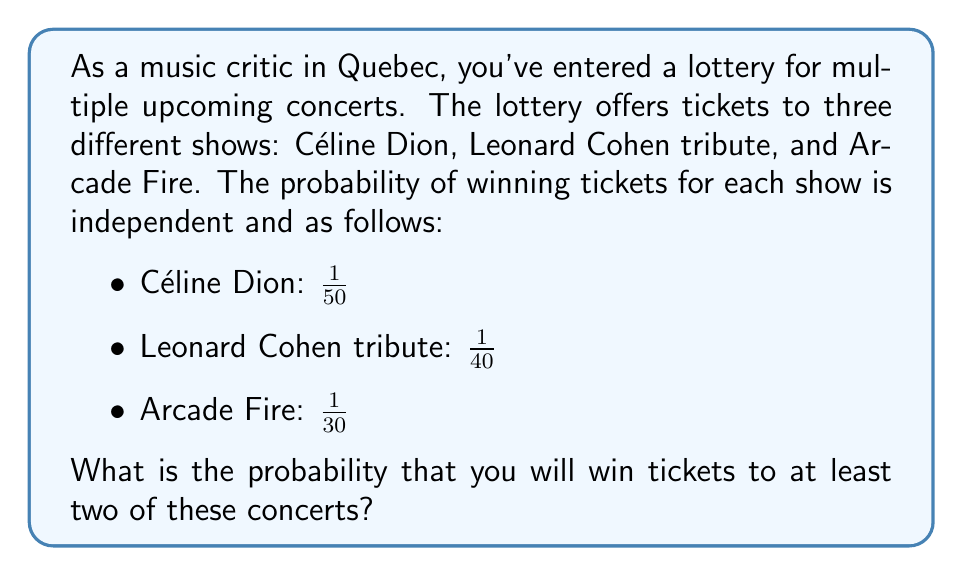Help me with this question. Let's approach this step-by-step:

1) First, we need to find the probability of winning tickets to at least two concerts. It's easier to calculate this by subtracting the probability of winning zero or one concert from 1.

2) Let's define events:
   A: Win Céline Dion tickets
   B: Win Leonard Cohen tribute tickets
   C: Win Arcade Fire tickets

3) Probabilities:
   $P(A) = \frac{1}{50}$, $P(B) = \frac{1}{40}$, $P(C) = \frac{1}{30}$

4) Probability of not winning each event:
   $P(\text{not A}) = 1 - \frac{1}{50} = \frac{49}{50}$
   $P(\text{not B}) = 1 - \frac{1}{40} = \frac{39}{40}$
   $P(\text{not C}) = 1 - \frac{1}{30} = \frac{29}{30}$

5) Probability of winning no tickets:
   $P(\text{no tickets}) = P(\text{not A}) \times P(\text{not B}) \times P(\text{not C})$
   $= \frac{49}{50} \times \frac{39}{40} \times \frac{29}{30} = 0.8575$

6) Probability of winning exactly one ticket:
   $P(\text{only A}) = \frac{1}{50} \times \frac{39}{40} \times \frac{29}{30} = 0.01225$
   $P(\text{only B}) = \frac{49}{50} \times \frac{1}{40} \times \frac{29}{30} = 0.01225$
   $P(\text{only C}) = \frac{49}{50} \times \frac{39}{40} \times \frac{1}{30} = 0.01225$
   
   $P(\text{exactly one ticket}) = 0.01225 + 0.01225 + 0.01225 = 0.03675$

7) Probability of winning at least two tickets:
   $P(\text{at least two}) = 1 - P(\text{no tickets}) - P(\text{exactly one ticket})$
   $= 1 - 0.8575 - 0.03675 = 0.10575$
Answer: The probability of winning tickets to at least two of these concerts is approximately $0.10575$ or $10.575\%$. 